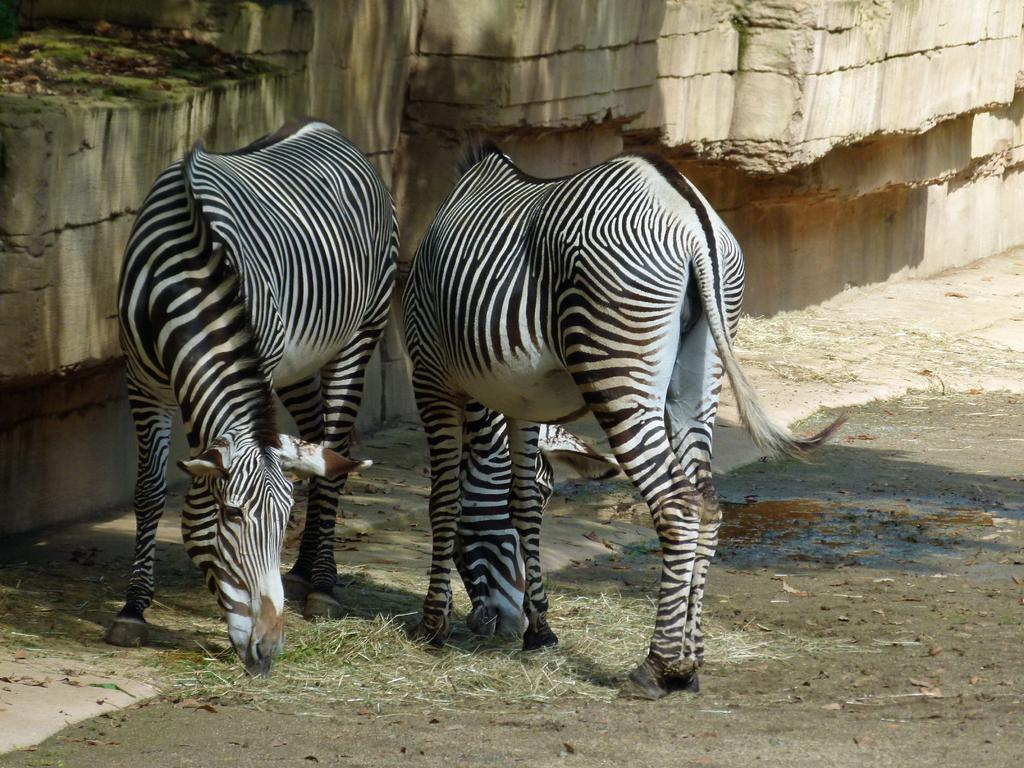What animals are present in the image? There are zebras in the image. What are the zebras doing in the image? The zebras are eating grass in the image. What can be seen in the background of the image? There is a wall in the image. What type of grape can be seen in the image? There is no grape present in the image; it features zebras eating grass. What subject is being taught to the students during recess in the image? There is no reference to students or a school setting in the image, so it's not possible to determine what subject might be taught during recess. 